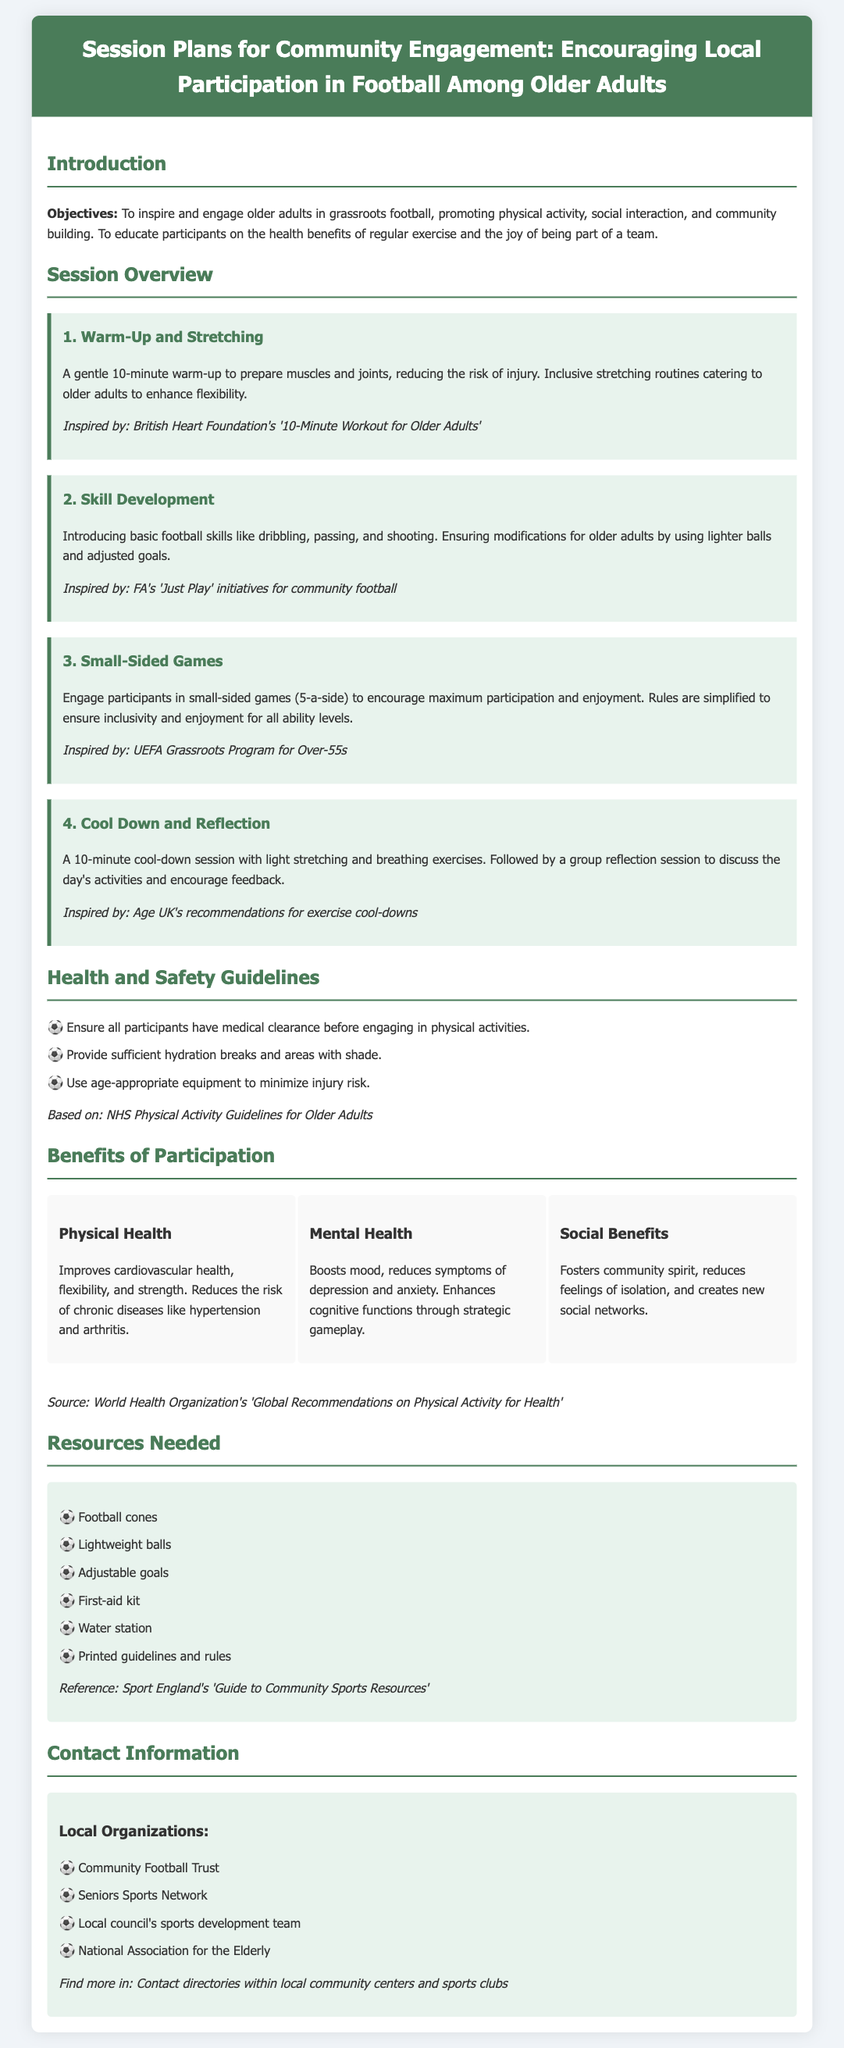What is the main objective of the session plans? The main objective is to inspire and engage older adults in grassroots football, promoting physical activity, social interaction, and community building.
Answer: To inspire and engage older adults How long is the warm-up session? The warm-up session is a gentle routine designed to prepare muscles, lasting for 10 minutes.
Answer: 10 minutes What type of games are included in the session? The session includes small-sided games (5-a-side) to encourage participation and enjoyment among participants.
Answer: Small-sided games (5-a-side) Which organization inspired the skill development section? The skill development section is inspired by the FA's 'Just Play' initiatives for community football.
Answer: FA's 'Just Play' Name one health benefit of regular exercise for older adults mentioned in the document. The document mentions that regular exercise improves cardiovascular health among older adults.
Answer: Cardiovascular health What is one guideline for health and safety mentioned? One guideline is to ensure all participants have medical clearance before engaging in physical activities.
Answer: Medical clearance What is one resource needed for the sessions? One of the resources needed for the sessions is lightweight balls.
Answer: Lightweight balls Which organization is listed as a local contact for older adults in football? The document lists the Community Football Trust as a local organization for contact.
Answer: Community Football Trust 